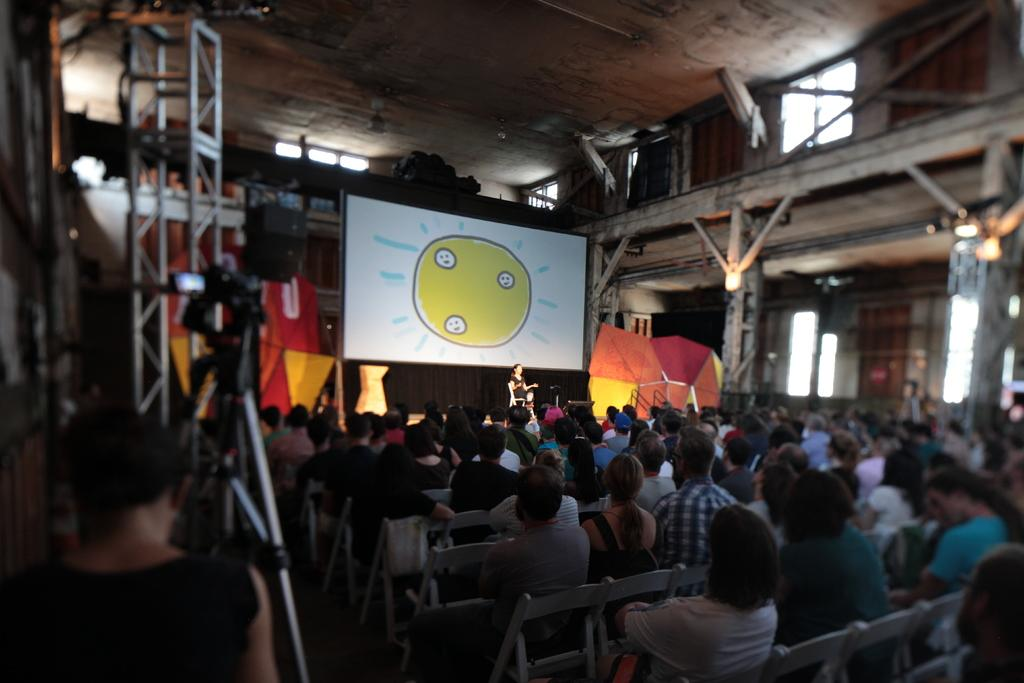How many people are in the image? There is a group of persons in the image. What are the persons in the image doing? The persons are sitting in a room. What color is the sheet in the background of the image? There is a white color sheet in the background of the image. What type of credit is being discussed by the group in the image? There is no indication in the image that the group is discussing credit or any financial matters. 